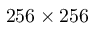Convert formula to latex. <formula><loc_0><loc_0><loc_500><loc_500>2 5 6 \times 2 5 6</formula> 